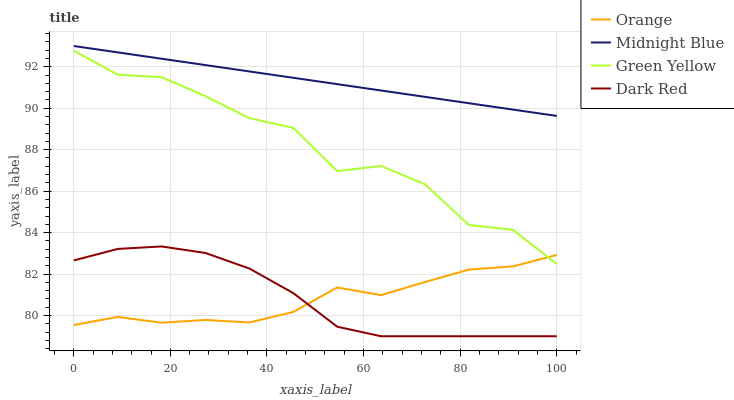Does Orange have the minimum area under the curve?
Answer yes or no. Yes. Does Midnight Blue have the maximum area under the curve?
Answer yes or no. Yes. Does Dark Red have the minimum area under the curve?
Answer yes or no. No. Does Dark Red have the maximum area under the curve?
Answer yes or no. No. Is Midnight Blue the smoothest?
Answer yes or no. Yes. Is Green Yellow the roughest?
Answer yes or no. Yes. Is Dark Red the smoothest?
Answer yes or no. No. Is Dark Red the roughest?
Answer yes or no. No. Does Dark Red have the lowest value?
Answer yes or no. Yes. Does Green Yellow have the lowest value?
Answer yes or no. No. Does Midnight Blue have the highest value?
Answer yes or no. Yes. Does Dark Red have the highest value?
Answer yes or no. No. Is Dark Red less than Green Yellow?
Answer yes or no. Yes. Is Midnight Blue greater than Green Yellow?
Answer yes or no. Yes. Does Orange intersect Green Yellow?
Answer yes or no. Yes. Is Orange less than Green Yellow?
Answer yes or no. No. Is Orange greater than Green Yellow?
Answer yes or no. No. Does Dark Red intersect Green Yellow?
Answer yes or no. No. 